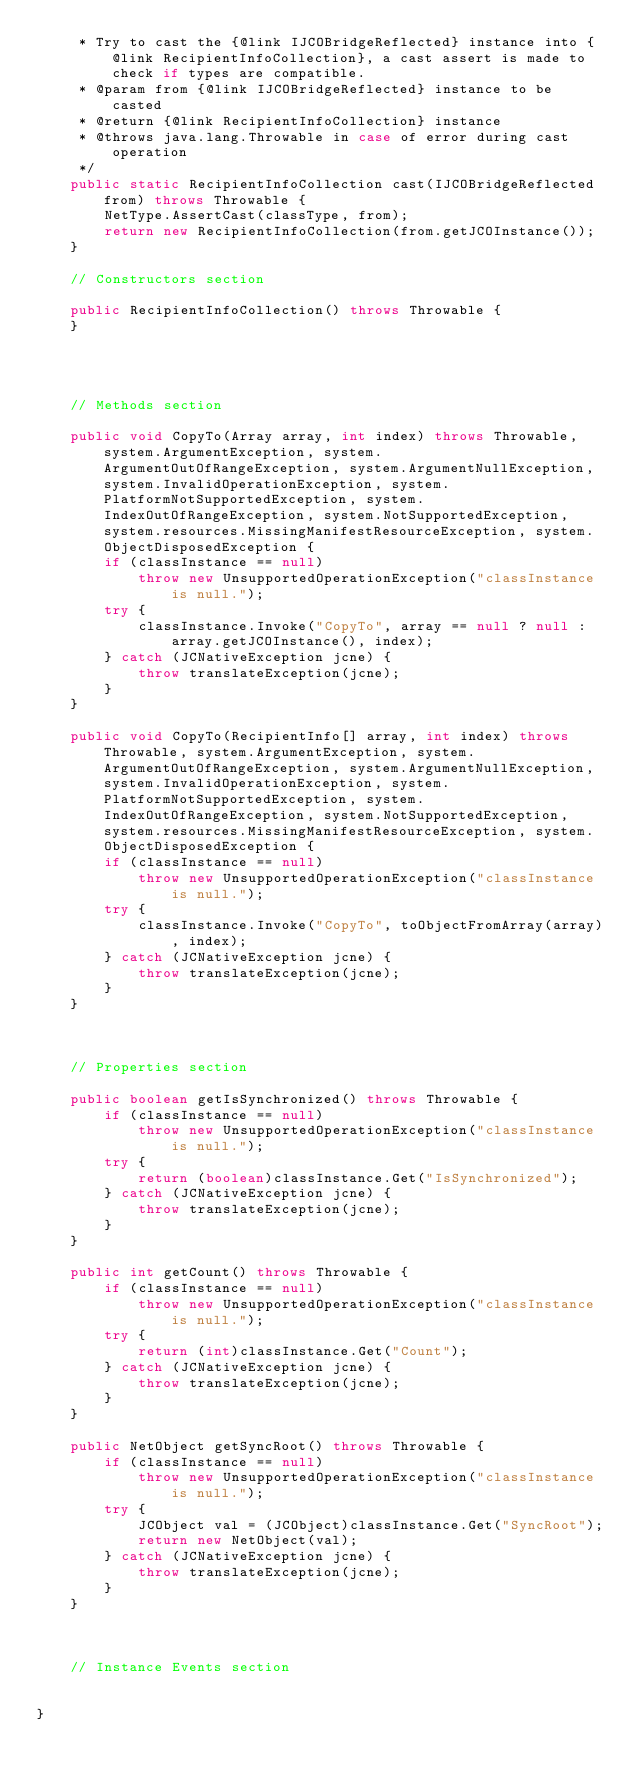Convert code to text. <code><loc_0><loc_0><loc_500><loc_500><_Java_>     * Try to cast the {@link IJCOBridgeReflected} instance into {@link RecipientInfoCollection}, a cast assert is made to check if types are compatible.
     * @param from {@link IJCOBridgeReflected} instance to be casted
     * @return {@link RecipientInfoCollection} instance
     * @throws java.lang.Throwable in case of error during cast operation
     */
    public static RecipientInfoCollection cast(IJCOBridgeReflected from) throws Throwable {
        NetType.AssertCast(classType, from);
        return new RecipientInfoCollection(from.getJCOInstance());
    }

    // Constructors section
    
    public RecipientInfoCollection() throws Throwable {
    }



    
    // Methods section
    
    public void CopyTo(Array array, int index) throws Throwable, system.ArgumentException, system.ArgumentOutOfRangeException, system.ArgumentNullException, system.InvalidOperationException, system.PlatformNotSupportedException, system.IndexOutOfRangeException, system.NotSupportedException, system.resources.MissingManifestResourceException, system.ObjectDisposedException {
        if (classInstance == null)
            throw new UnsupportedOperationException("classInstance is null.");
        try {
            classInstance.Invoke("CopyTo", array == null ? null : array.getJCOInstance(), index);
        } catch (JCNativeException jcne) {
            throw translateException(jcne);
        }
    }

    public void CopyTo(RecipientInfo[] array, int index) throws Throwable, system.ArgumentException, system.ArgumentOutOfRangeException, system.ArgumentNullException, system.InvalidOperationException, system.PlatformNotSupportedException, system.IndexOutOfRangeException, system.NotSupportedException, system.resources.MissingManifestResourceException, system.ObjectDisposedException {
        if (classInstance == null)
            throw new UnsupportedOperationException("classInstance is null.");
        try {
            classInstance.Invoke("CopyTo", toObjectFromArray(array), index);
        } catch (JCNativeException jcne) {
            throw translateException(jcne);
        }
    }


    
    // Properties section
    
    public boolean getIsSynchronized() throws Throwable {
        if (classInstance == null)
            throw new UnsupportedOperationException("classInstance is null.");
        try {
            return (boolean)classInstance.Get("IsSynchronized");
        } catch (JCNativeException jcne) {
            throw translateException(jcne);
        }
    }

    public int getCount() throws Throwable {
        if (classInstance == null)
            throw new UnsupportedOperationException("classInstance is null.");
        try {
            return (int)classInstance.Get("Count");
        } catch (JCNativeException jcne) {
            throw translateException(jcne);
        }
    }

    public NetObject getSyncRoot() throws Throwable {
        if (classInstance == null)
            throw new UnsupportedOperationException("classInstance is null.");
        try {
            JCObject val = (JCObject)classInstance.Get("SyncRoot");
            return new NetObject(val);
        } catch (JCNativeException jcne) {
            throw translateException(jcne);
        }
    }



    // Instance Events section
    

}</code> 